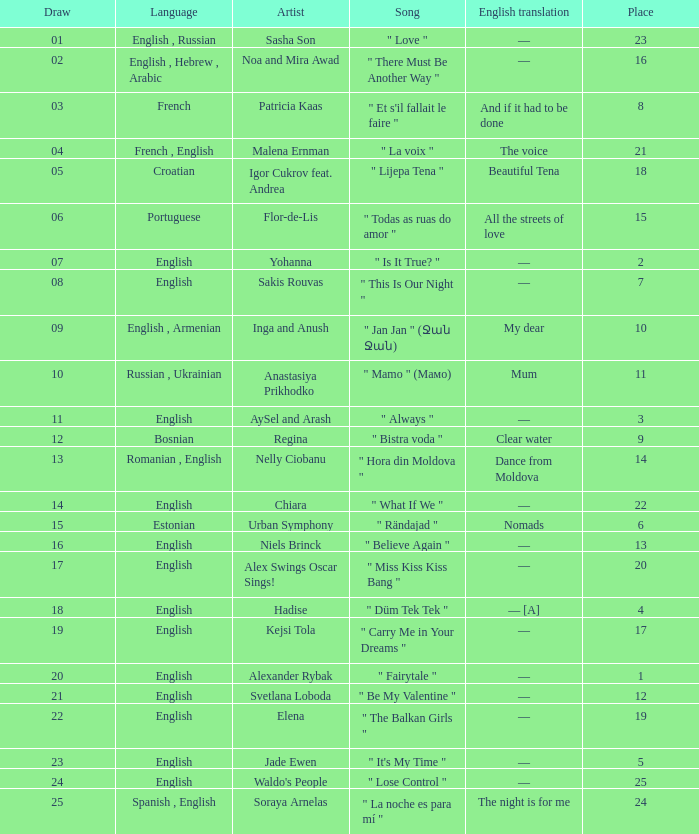What was the english rendition of the song by svetlana loboda? —. 